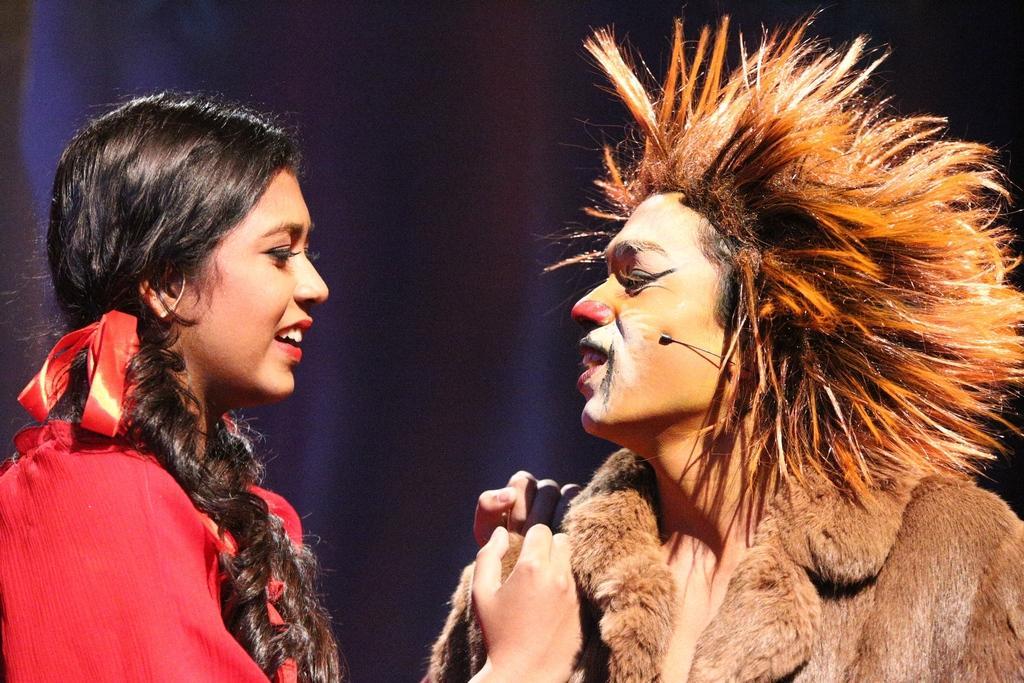Please provide a concise description of this image. On the left side of the image there is a lady with red dress. In front of her there is a person with costume and painting on the face and there is a mic. Behind them there is a dark background. 